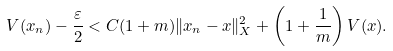<formula> <loc_0><loc_0><loc_500><loc_500>V ( x _ { n } ) - \frac { \varepsilon } { 2 } < C ( 1 + m ) \| x _ { n } - x \| ^ { 2 } _ { X } + \left ( 1 + \frac { 1 } { m } \right ) V ( x ) .</formula> 